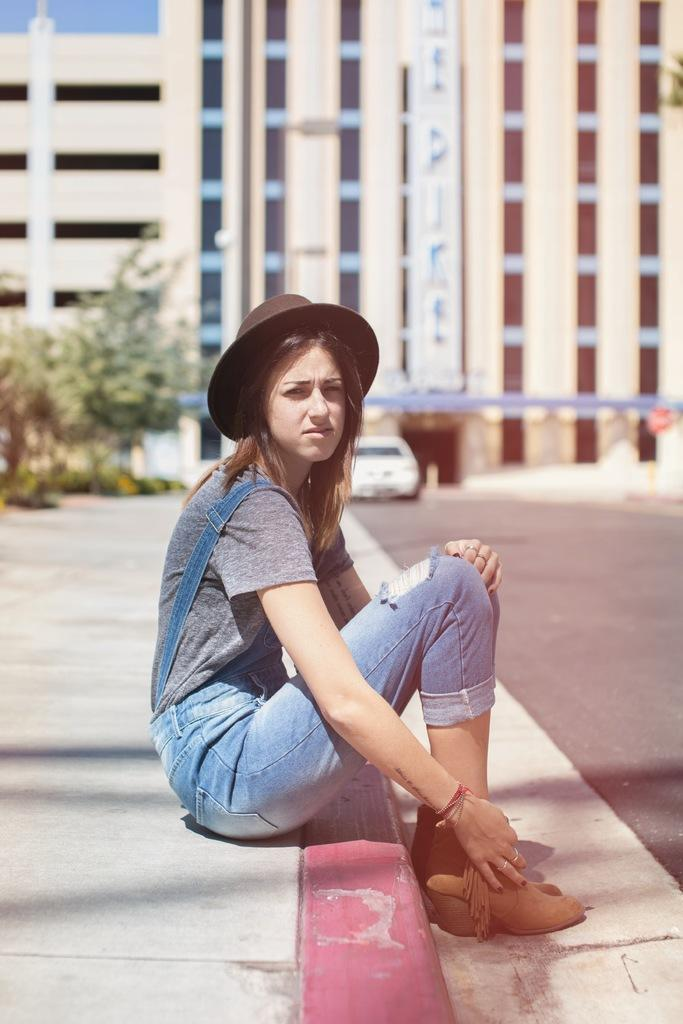What is the woman in the image doing? The woman is sitting on a fence in the image. What can be seen in the background of the image? There are plants, a car, buildings, and the sky visible in the background of the image. What is the weather like in the image? The image was taken during a sunny day. What type of vest is the woman wearing in the image? There is no vest visible in the image; the woman is not wearing any clothing items mentioned in the facts. 